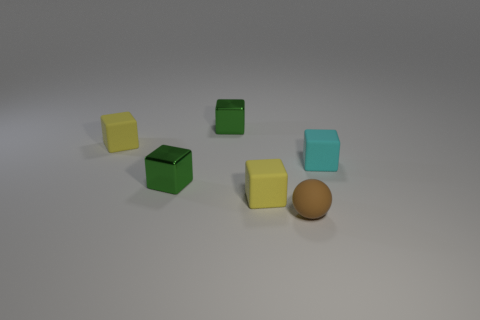Are there an equal number of tiny cyan rubber things that are in front of the small cyan matte thing and large cyan spheres?
Make the answer very short. Yes. What number of objects are yellow rubber cubes that are behind the small brown ball or shiny blocks?
Your answer should be compact. 4. There is a small metallic thing that is in front of the cyan object; does it have the same color as the matte ball?
Offer a terse response. No. How big is the metallic thing that is behind the small cyan block?
Offer a terse response. Small. There is a small yellow matte object that is in front of the cube on the right side of the sphere; what shape is it?
Your answer should be very brief. Cube. There is a green metallic block that is behind the cyan rubber object; does it have the same size as the small cyan rubber thing?
Provide a short and direct response. Yes. How many small cyan things have the same material as the tiny ball?
Give a very brief answer. 1. There is a brown sphere that is in front of the small metallic object that is in front of the tiny cube that is to the right of the matte ball; what is it made of?
Make the answer very short. Rubber. What color is the small metal cube behind the rubber block to the right of the small brown ball?
Your answer should be compact. Green. What number of small objects are green shiny things or yellow things?
Offer a very short reply. 4. 